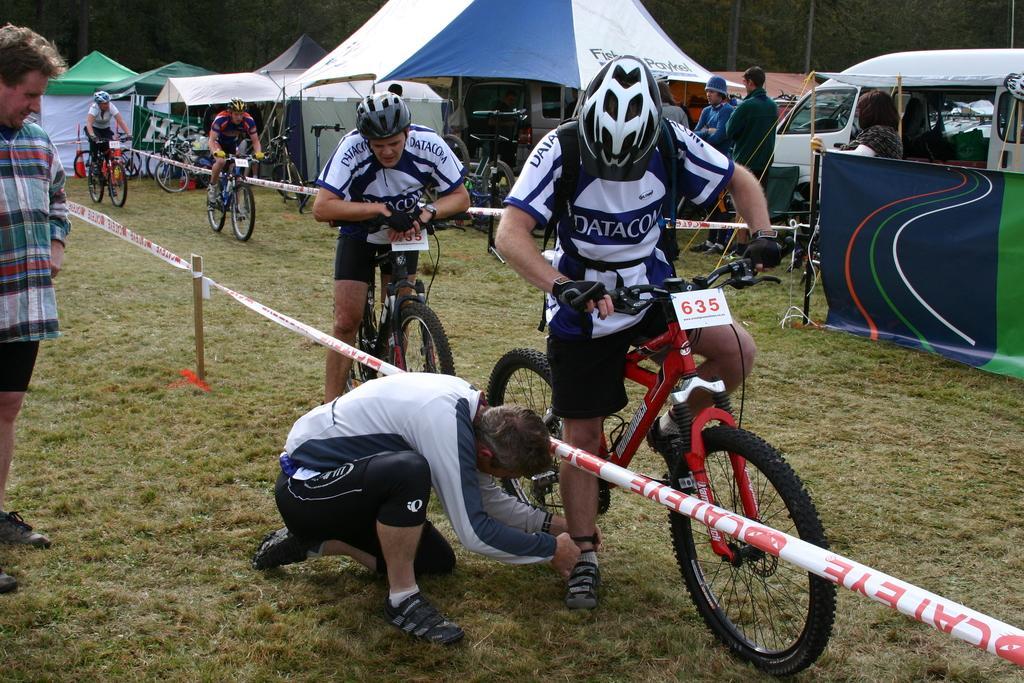How would you summarize this image in a sentence or two? In this picture I can see bicycles. On some bicycles people are sitting. These people are wearing helmets. In the background I can see some people, tents, vehicles, mobile fence barrier and grass. I can also see some other objects on the ground. 